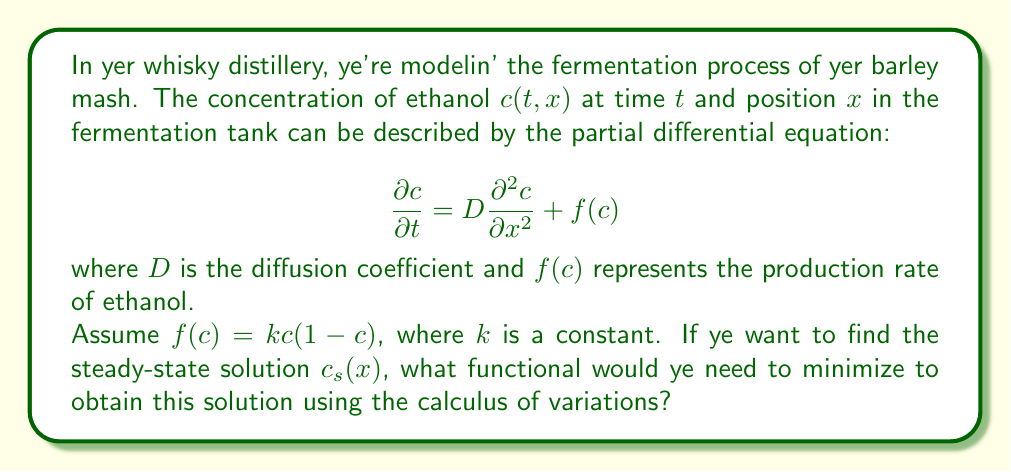Provide a solution to this math problem. To solve this problem, we need to follow these steps:

1. Recognize that the steady-state solution $c_s(x)$ satisfies:

   $$0 = D\frac{d^2 c_s}{dx^2} + f(c_s)$$

2. This equation can be derived as the Euler-Lagrange equation of a functional. To find this functional, we need to identify a function $F(c_s, c_s')$ such that:

   $$\frac{d}{dx}\left(\frac{\partial F}{\partial c_s'}\right) - \frac{\partial F}{\partial c_s} = 0$$

   is equivalent to our steady-state equation.

3. By inspection, we can see that:

   $$F(c_s, c_s') = \frac{D}{2}(c_s')^2 - \int f(c_s) dc_s$$

   satisfies this condition.

4. Given $f(c) = kc(1-c)$, we can calculate:

   $$\int f(c_s) dc_s = \int kc_s(1-c_s) dc_s = k\left(\frac{c_s^2}{2} - \frac{c_s^3}{3}\right) + C$$

5. Therefore, the functional to be minimized is:

   $$J[c_s] = \int_0^L \left[\frac{D}{2}(c_s')^2 - k\left(\frac{c_s^2}{2} - \frac{c_s^3}{3}\right)\right] dx$$

   where $L$ is the length of the fermentation tank.

This functional represents the total energy of the system, balancing the diffusion (first term) and the production (second term) of ethanol.
Answer: The functional to be minimized is:

$$J[c_s] = \int_0^L \left[\frac{D}{2}(c_s')^2 - k\left(\frac{c_s^2}{2} - \frac{c_s^3}{3}\right)\right] dx$$ 